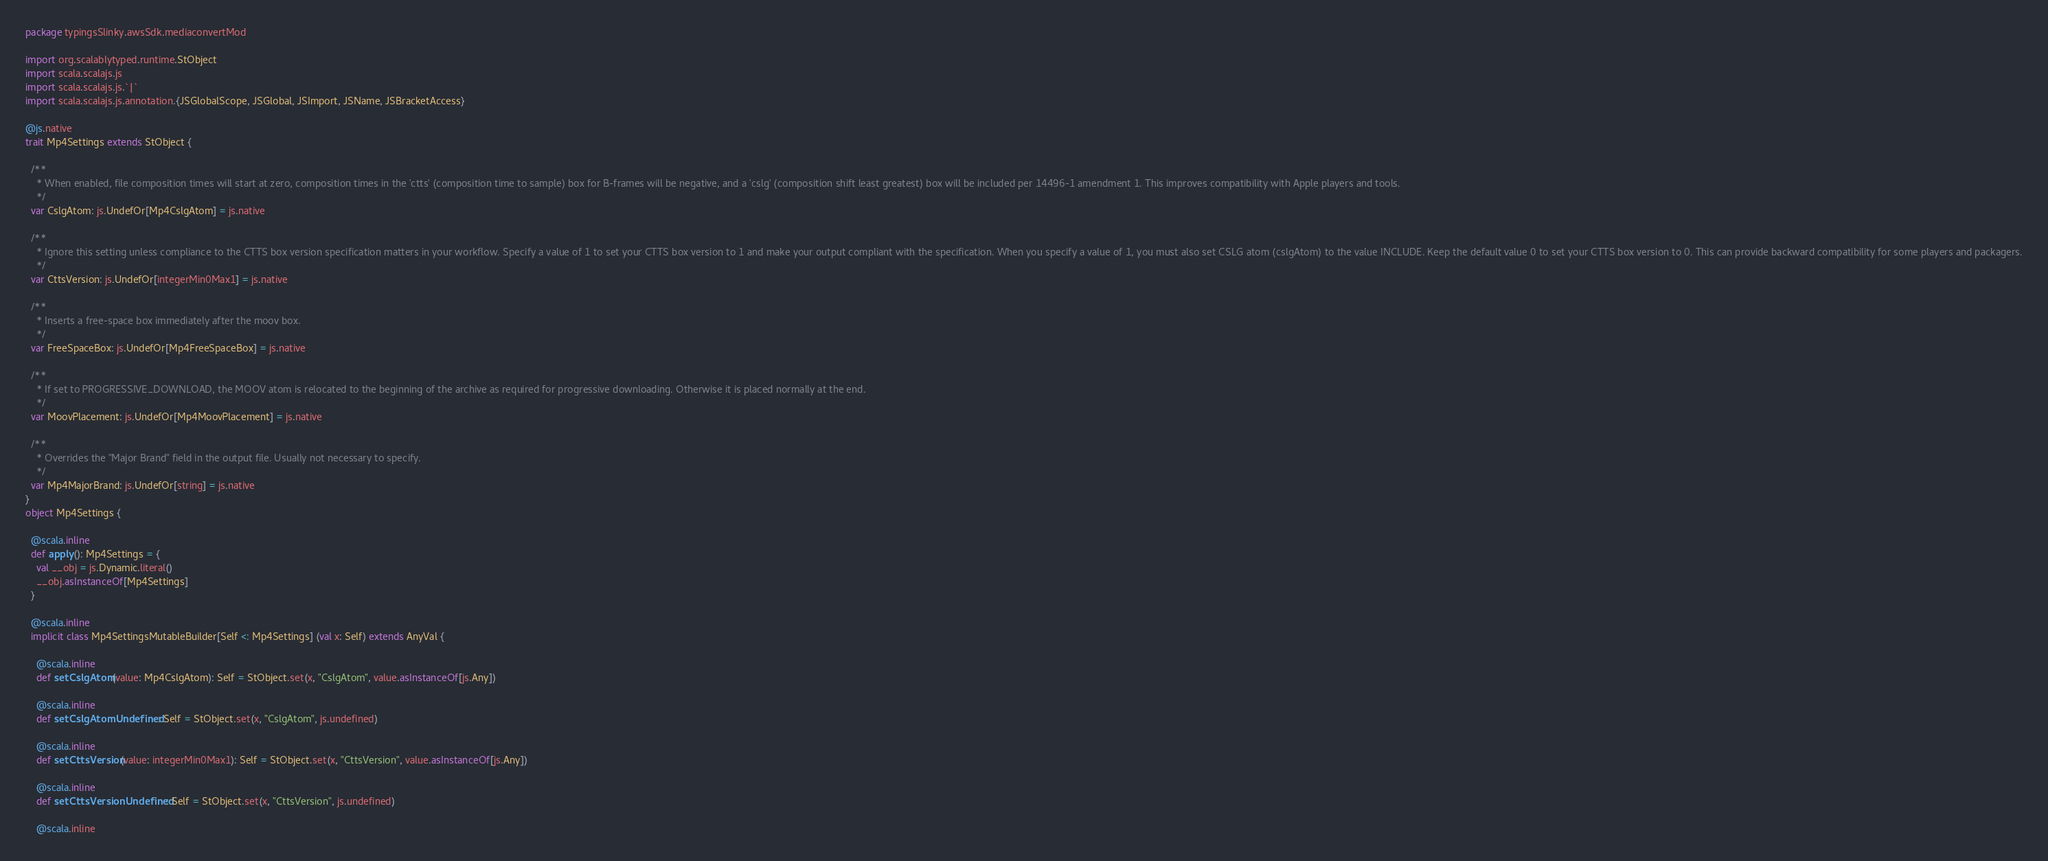<code> <loc_0><loc_0><loc_500><loc_500><_Scala_>package typingsSlinky.awsSdk.mediaconvertMod

import org.scalablytyped.runtime.StObject
import scala.scalajs.js
import scala.scalajs.js.`|`
import scala.scalajs.js.annotation.{JSGlobalScope, JSGlobal, JSImport, JSName, JSBracketAccess}

@js.native
trait Mp4Settings extends StObject {
  
  /**
    * When enabled, file composition times will start at zero, composition times in the 'ctts' (composition time to sample) box for B-frames will be negative, and a 'cslg' (composition shift least greatest) box will be included per 14496-1 amendment 1. This improves compatibility with Apple players and tools.
    */
  var CslgAtom: js.UndefOr[Mp4CslgAtom] = js.native
  
  /**
    * Ignore this setting unless compliance to the CTTS box version specification matters in your workflow. Specify a value of 1 to set your CTTS box version to 1 and make your output compliant with the specification. When you specify a value of 1, you must also set CSLG atom (cslgAtom) to the value INCLUDE. Keep the default value 0 to set your CTTS box version to 0. This can provide backward compatibility for some players and packagers.
    */
  var CttsVersion: js.UndefOr[integerMin0Max1] = js.native
  
  /**
    * Inserts a free-space box immediately after the moov box.
    */
  var FreeSpaceBox: js.UndefOr[Mp4FreeSpaceBox] = js.native
  
  /**
    * If set to PROGRESSIVE_DOWNLOAD, the MOOV atom is relocated to the beginning of the archive as required for progressive downloading. Otherwise it is placed normally at the end.
    */
  var MoovPlacement: js.UndefOr[Mp4MoovPlacement] = js.native
  
  /**
    * Overrides the "Major Brand" field in the output file. Usually not necessary to specify.
    */
  var Mp4MajorBrand: js.UndefOr[string] = js.native
}
object Mp4Settings {
  
  @scala.inline
  def apply(): Mp4Settings = {
    val __obj = js.Dynamic.literal()
    __obj.asInstanceOf[Mp4Settings]
  }
  
  @scala.inline
  implicit class Mp4SettingsMutableBuilder[Self <: Mp4Settings] (val x: Self) extends AnyVal {
    
    @scala.inline
    def setCslgAtom(value: Mp4CslgAtom): Self = StObject.set(x, "CslgAtom", value.asInstanceOf[js.Any])
    
    @scala.inline
    def setCslgAtomUndefined: Self = StObject.set(x, "CslgAtom", js.undefined)
    
    @scala.inline
    def setCttsVersion(value: integerMin0Max1): Self = StObject.set(x, "CttsVersion", value.asInstanceOf[js.Any])
    
    @scala.inline
    def setCttsVersionUndefined: Self = StObject.set(x, "CttsVersion", js.undefined)
    
    @scala.inline</code> 